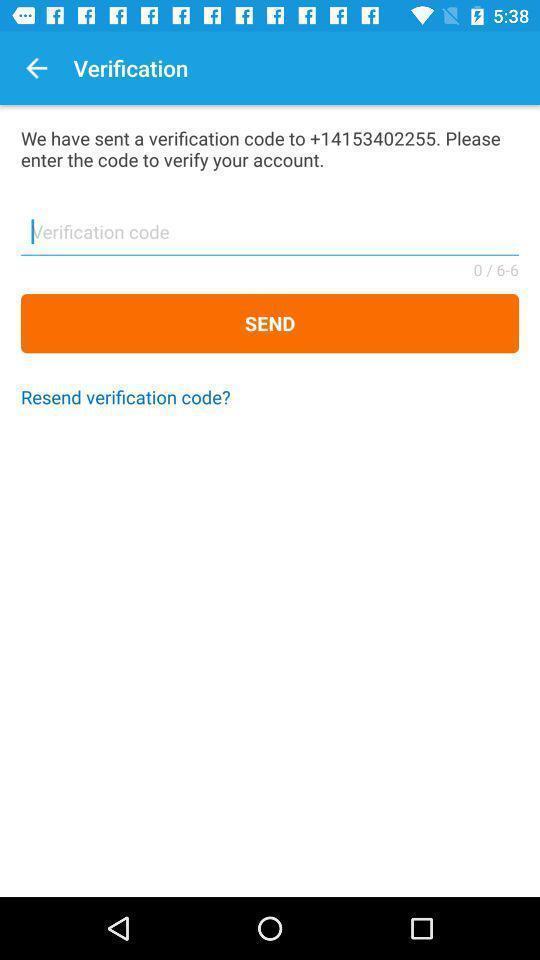Tell me what you see in this picture. Page shows to enter the verification code. 